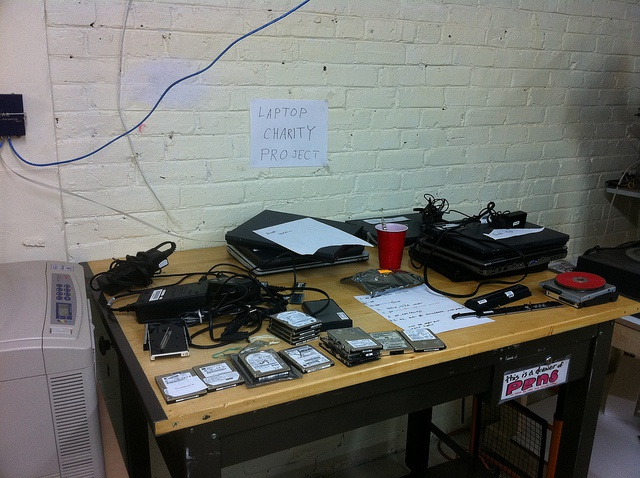Describe the objects in this image and their specific colors. I can see laptop in darkgray, black, lightblue, and purple tones, laptop in darkgray, black, and gray tones, laptop in darkgray, black, gray, purple, and darkgreen tones, laptop in darkgray, black, maroon, and gray tones, and cup in darkgray, maroon, and gray tones in this image. 